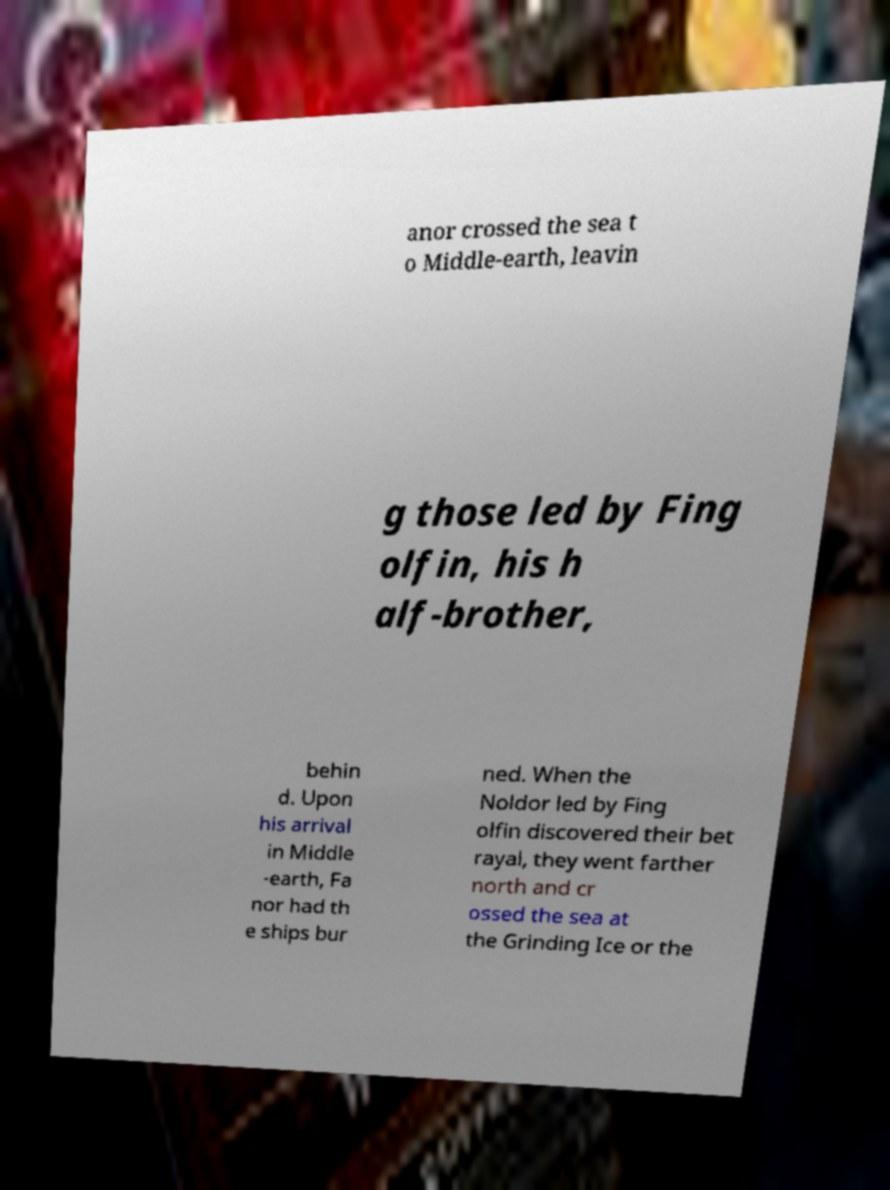Can you read and provide the text displayed in the image?This photo seems to have some interesting text. Can you extract and type it out for me? anor crossed the sea t o Middle-earth, leavin g those led by Fing olfin, his h alf-brother, behin d. Upon his arrival in Middle -earth, Fa nor had th e ships bur ned. When the Noldor led by Fing olfin discovered their bet rayal, they went farther north and cr ossed the sea at the Grinding Ice or the 